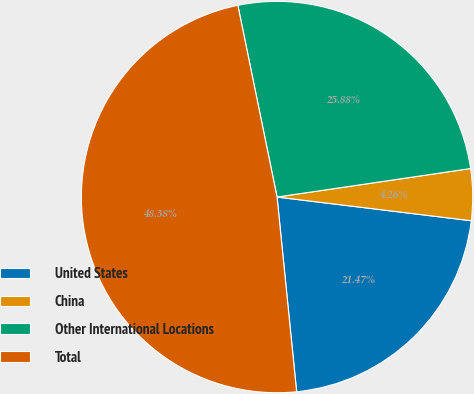<chart> <loc_0><loc_0><loc_500><loc_500><pie_chart><fcel>United States<fcel>China<fcel>Other International Locations<fcel>Total<nl><fcel>21.47%<fcel>4.26%<fcel>25.88%<fcel>48.38%<nl></chart> 